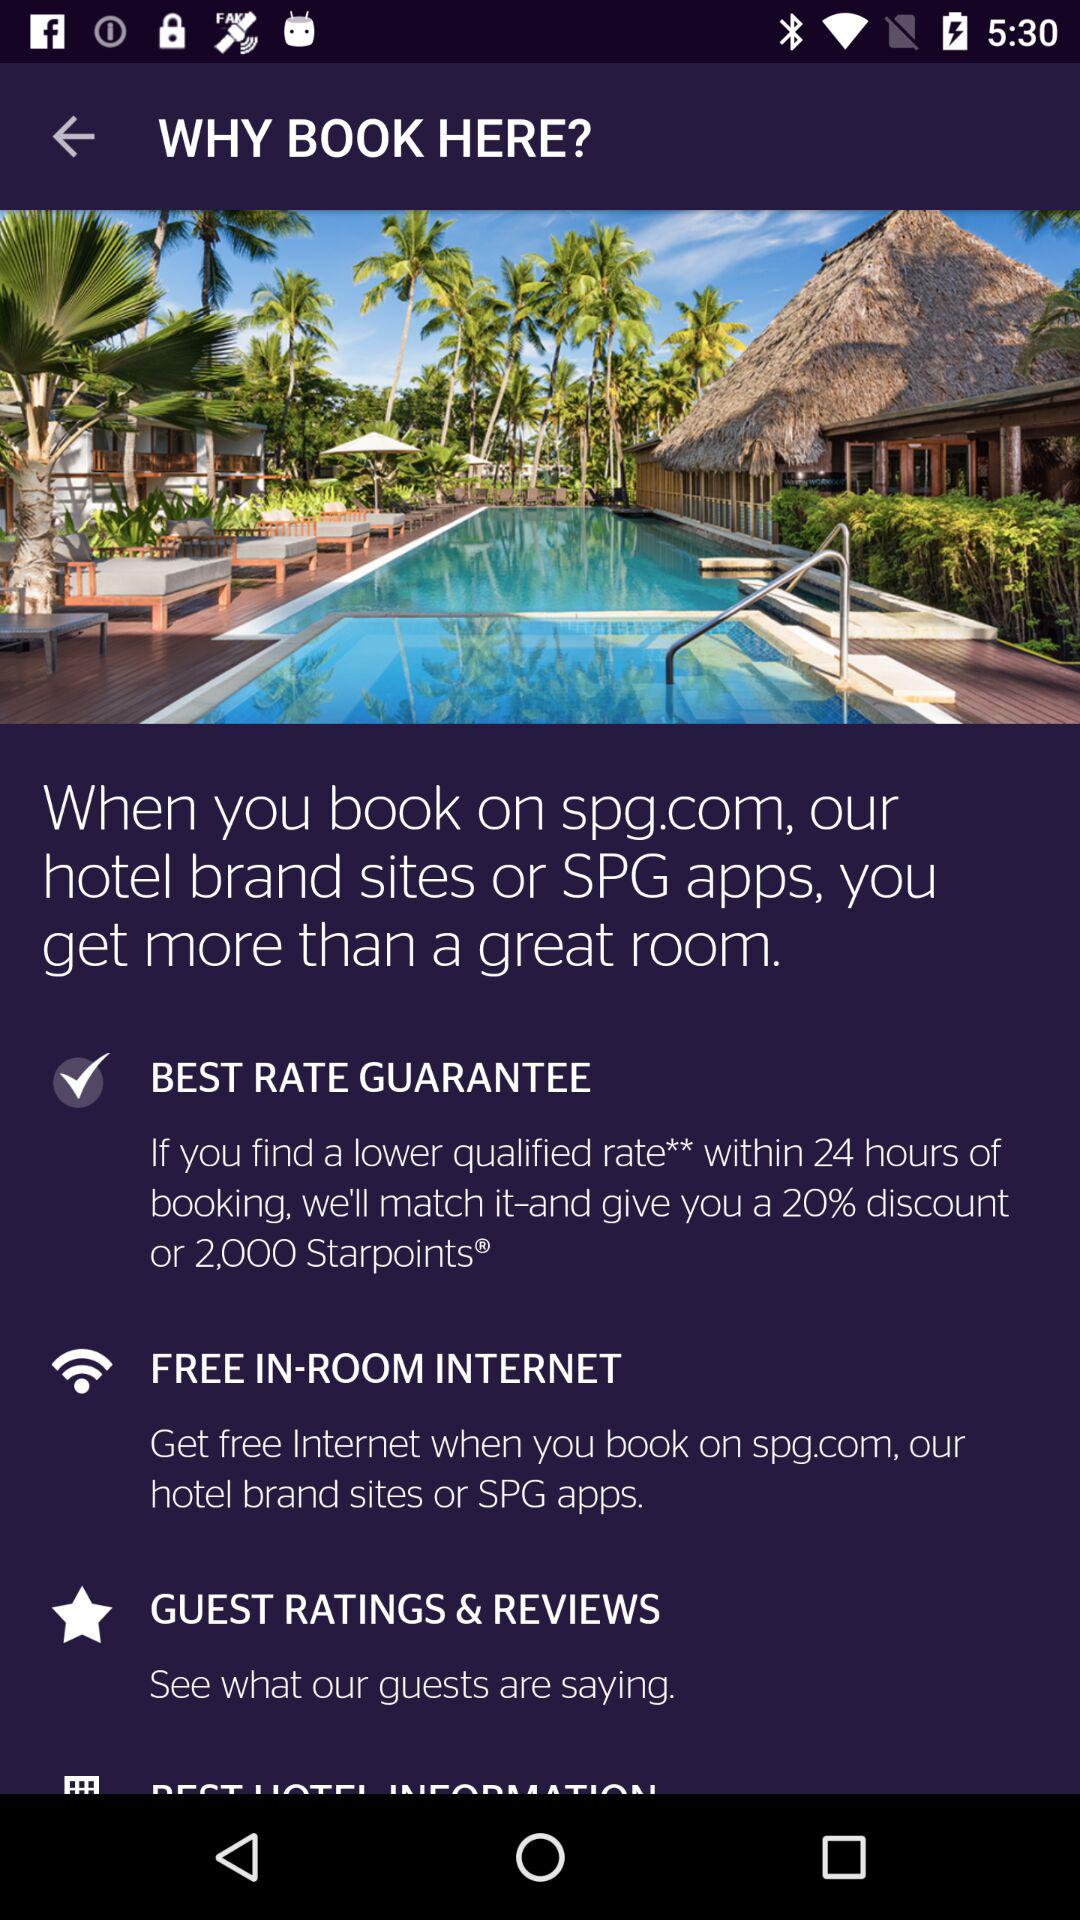How much of a discount is there on booking? There is a 20% discount on booking. 